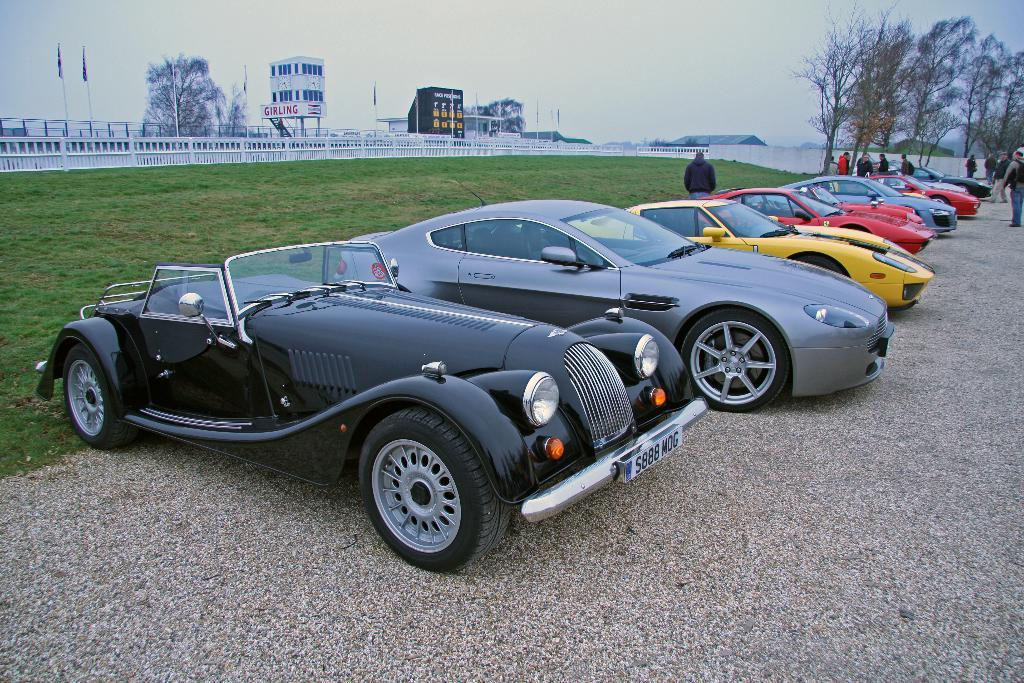What types of vehicles can be seen in the image? There are motor vehicles in the image. What are the people in the image doing? There are persons standing on the road in the image. What natural elements are present in the image? There are trees in the image. What structures are visible in the image? There are grills, flags, flag posts, buildings, and sheds in the image. What part of the natural environment is visible in the image? The sky is visible in the image. What additional feature can be seen in the image? There is a name board in the image. Can you tell me how many porters are carrying luggage in the image? There are no porters carrying luggage in the image. --- Facts: 1. There is a person in the image. 12. The person is wearing a hat. 13. The person is holding a book. 14. The person is standing on a bridge. 15. There is a river flowing under the bridge. 16. There are birds flying in the sky. 17. There are clouds in the sky. 18. There are mountains in the background. 19. There are trees on the mountains. 120. There are flowers growing on the sides of the bridge. Absurd Topics: unicorn, magic wand, fairy Conversation: Who or what is present in the image? There is a person in the image. What is the person wearing? The person is wearing a hat. What is the person holding? The person is holding a book. Where is the person standing? The person is standing on a bridge. What can be seen flowing under the bridge? There is a river flowing under the bridge. What is happening in the sky? There are birds flying in the sky. What else can be seen in the sky? There are clouds in the sky. What can be seen in the background? There are mountains in the background. What can be seen on the mountains? There are trees on the mountains. What can be seen growing on the sides of the bridge? There are flowers growing on the sides of the bridge. Reasoning: Let's think step by step in order to produce the conversation. We start by identifying the main subject in the image, which is the person. Then, we describe specific features of the person, such as the hat and the book they are holding. Next, we observe the location of the person, noting that they are standing on a bridge. We then describe the natural environment visible in the image, including the river, the birds, the clouds, the mountains, the trees, and the flowers. Each question is designed to elicit a specific detail about the image that is known from the provided facts. Absurd Question/Answer: Can you see a unicorn in the image? No, 